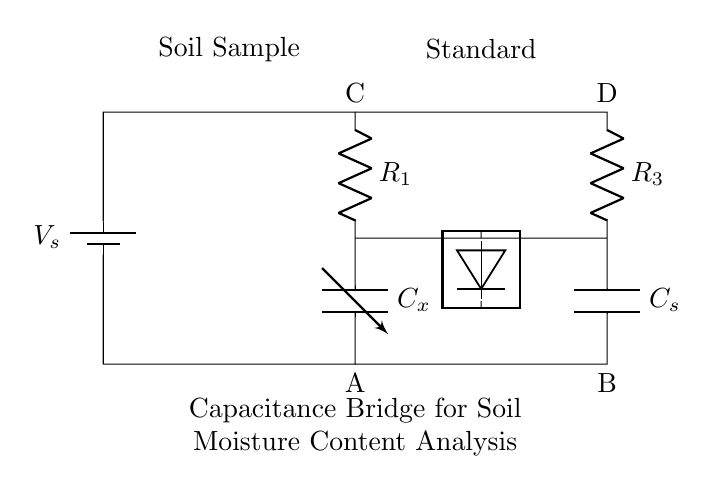What type of circuit is depicted in the diagram? The circuit is a capacitance bridge, as indicated by the arrangement of the variable capacitor and standard capacitor being used for measurement and comparison.
Answer: capacitance bridge What is the role of capacitor C_x in the circuit? Capacitor C_x represents the soil sample whose moisture content is being analyzed. It provides variable capacitance based on the moisture level of the soil.
Answer: soil sample What component measures the difference in capacitance in the circuit? The detector is the component that measures the difference in capacitance between C_x and C_s, helping to evaluate the soil moisture content.
Answer: detector How many resistors are present in the circuit? There are two resistors (R_1 and R_3) present in the capacitance bridge circuit, connecting the different sections.
Answer: two What happens if the value of C_x increases? If the value of C_x increases due to higher soil moisture content, it alters the balance in the bridge circuit, causing a change in the reading at the detector.
Answer: alters balance Which components would be affected if the soil moisture content decreases? If soil moisture content decreases, C_x would decrease in capacitance, affecting the balance of the bridge and leading to a different reading at the detector.
Answer: C_x and the detector reading What is the main purpose of R_3 in this circuit? R_3 helps to provide a reference resistance, which stabilizes the circuit and is essential for determining the balance between the variable capacitor and the standard capacitor.
Answer: reference resistance 